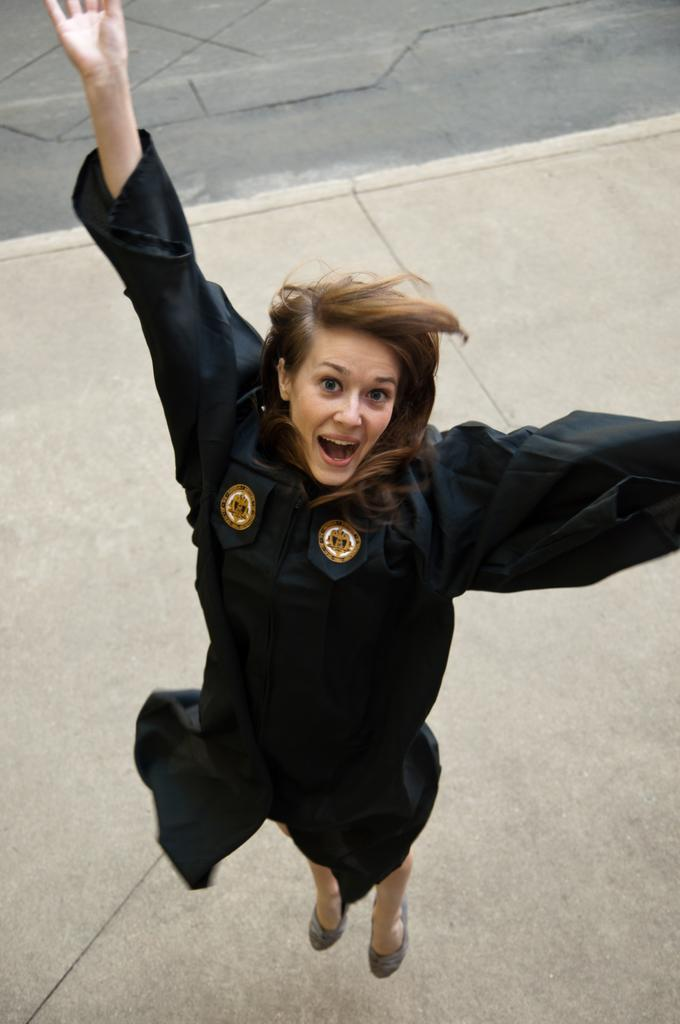Who is present in the image? There is a woman in the image. What is the woman doing in the image? The woman is smiling in the image. What is the woman wearing in the image? The woman is wearing a black dress in the image. What can be seen in the background of the image? There is ground visible in the background of the image. What type of leaf is the woman holding in the image? A: There is no leaf present in the image; the woman is not holding anything. 